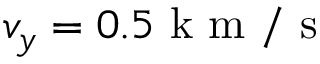<formula> <loc_0><loc_0><loc_500><loc_500>v _ { y } = 0 . 5 k m / s</formula> 